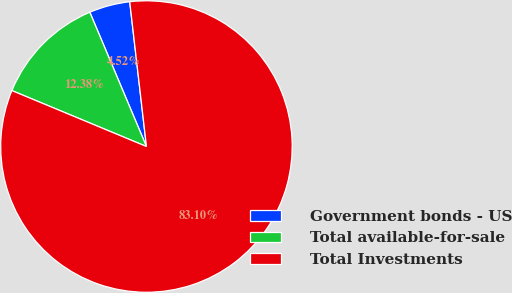Convert chart. <chart><loc_0><loc_0><loc_500><loc_500><pie_chart><fcel>Government bonds - US<fcel>Total available-for-sale<fcel>Total Investments<nl><fcel>4.52%<fcel>12.38%<fcel>83.1%<nl></chart> 